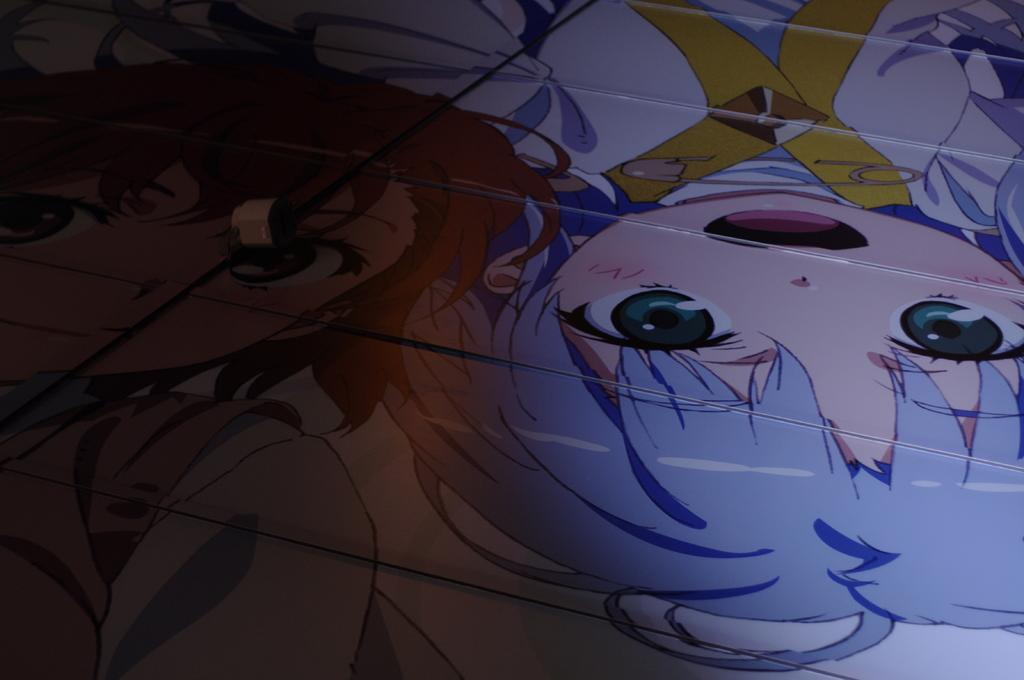What type of characters are in the foreground of the image? There are anime characters in the foreground of the image. Can you describe the positioning of the anime characters? One anime character is on the left side, and one anime character is on the right side. How many kitties are shaking hands in the image? There are no kitties or any hand-shaking activity present in the image. 